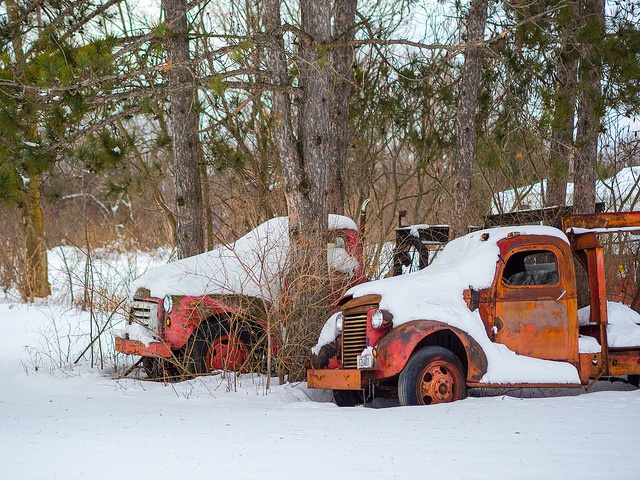Describe the objects in this image and their specific colors. I can see truck in gray, lightgray, black, maroon, and brown tones and truck in gray, lightgray, black, brown, and darkgray tones in this image. 